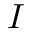<formula> <loc_0><loc_0><loc_500><loc_500>I</formula> 